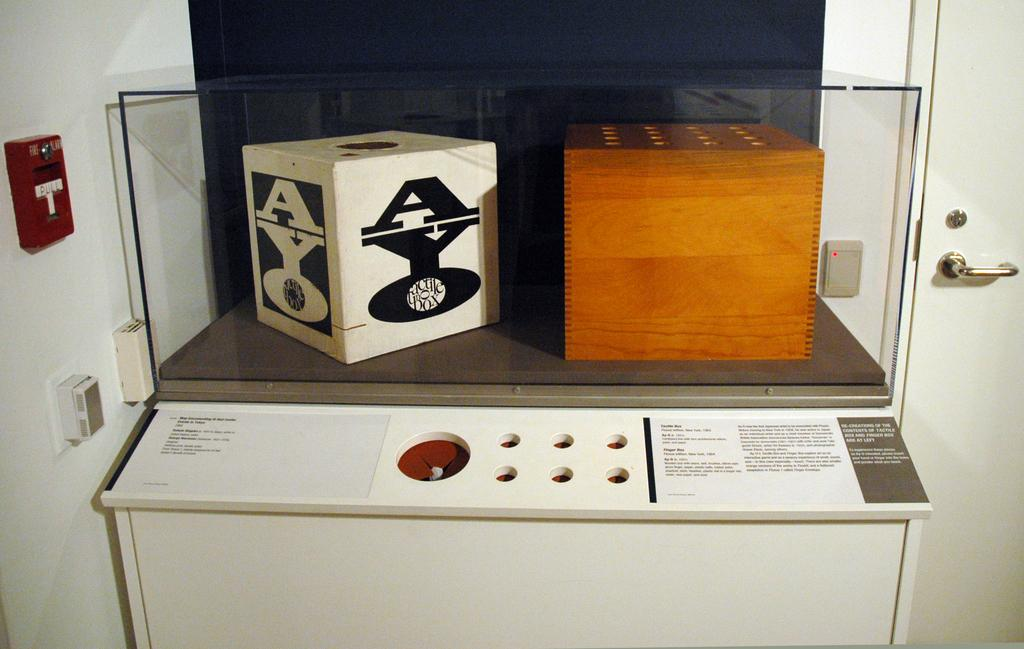<image>
Give a short and clear explanation of the subsequent image. A white display case has a white box labeled "AYO" vertically on the left of another wooden box. 